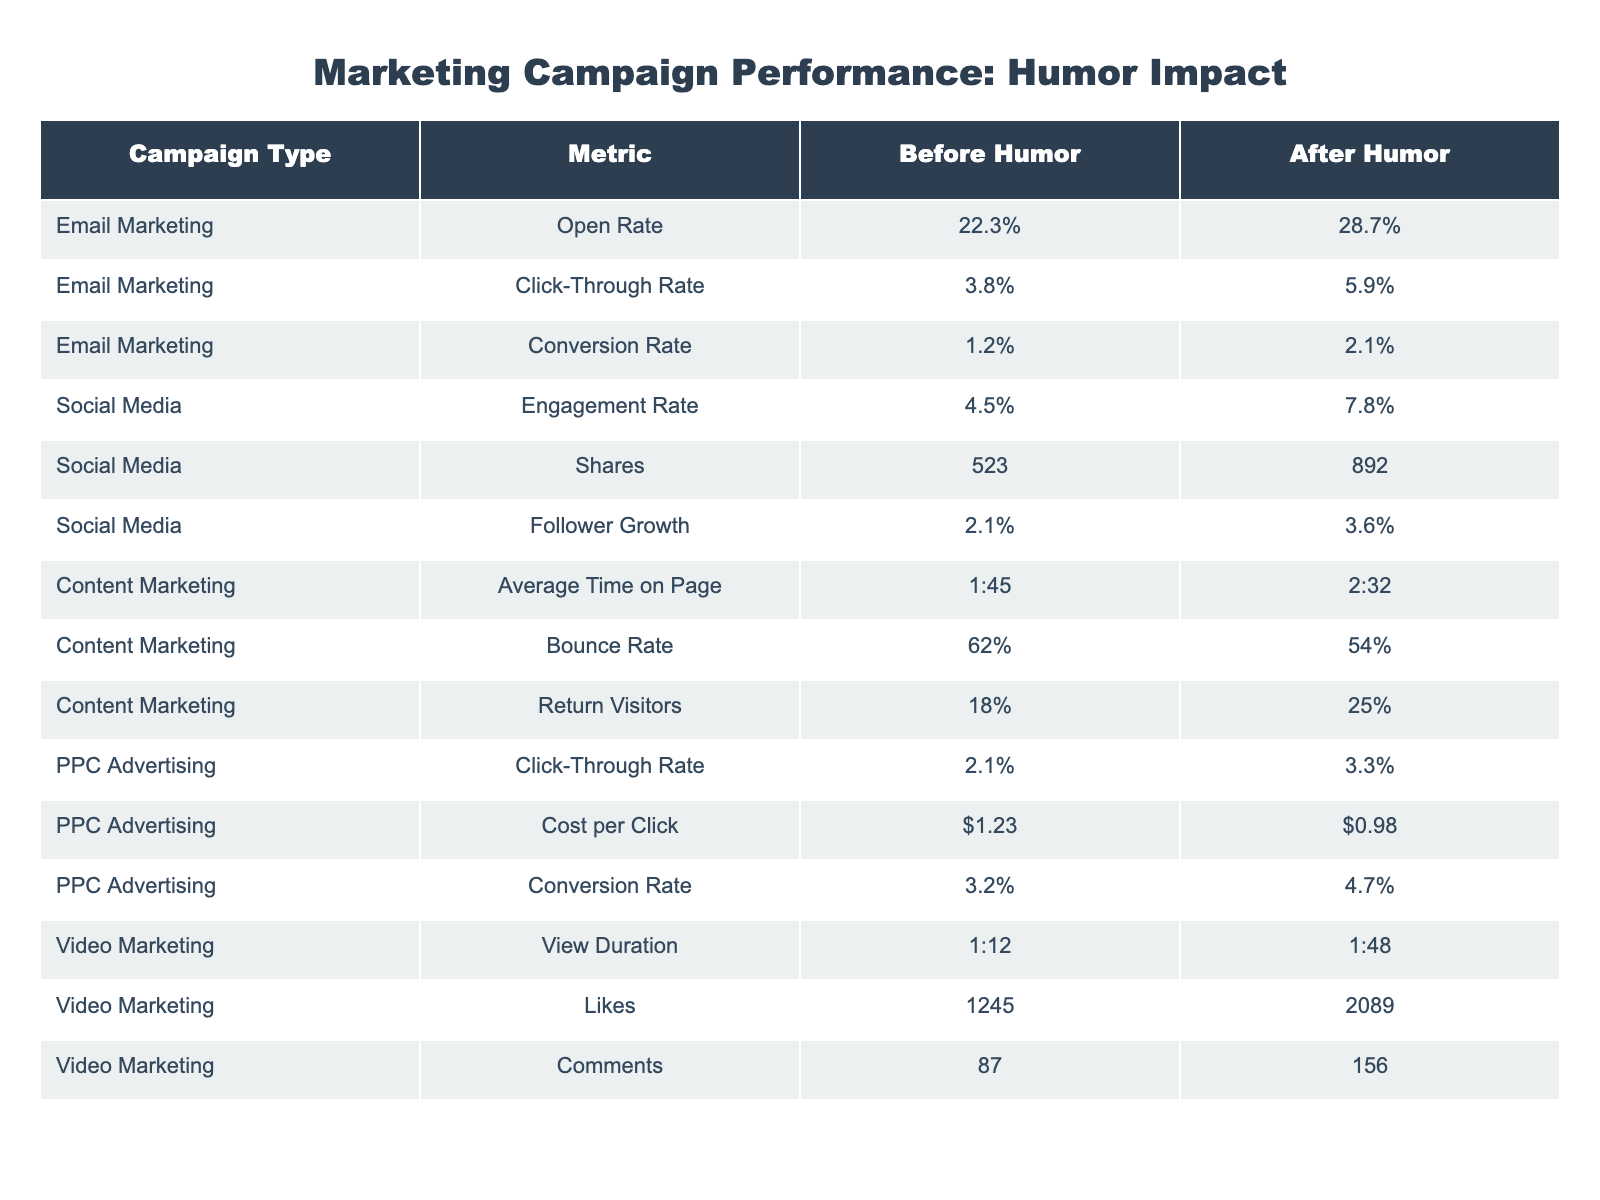What was the open rate for email marketing after humor was incorporated? The table shows that the open rate for email marketing after humor was 28.7%.
Answer: 28.7% Which campaign type experienced the highest increase in engagement rate after humor was added? The social media campaign type had the highest increase in engagement rate, going from 4.5% to 7.8%, which is an increase of 3.3 percentage points.
Answer: Social Media What is the percentage difference in conversion rate for PPC advertising before and after humor? The conversion rate for PPC advertising before humor was 3.2% and after was 4.7%. The percentage difference is calculated as (4.7 - 3.2) = 1.5%.
Answer: 1.5% Did content marketing have a lower bounce rate after incorporating humor? Yes, content marketing's bounce rate improved from 62% to 54% after humor was incorporated.
Answer: Yes What was the average increase in click-through rate for email marketing and PPC advertising combined after humor was added? The click-through rate for email marketing increased from 3.8% to 5.9% (an increase of 2.1%) and for PPC advertising from 2.1% to 3.3% (an increase of 1.2%). The average increase is (2.1 + 1.2) / 2 = 1.65%.
Answer: 1.65% Which campaign had the greatest absolute increase in likes after the incorporation of humor? Video marketing had the greatest absolute increase in likes, from 1245 to 2089. The increase is calculated as 2089 - 1245 = 844.
Answer: 844 What metric improved the least for email marketing after humor was incorporated? The metric that improved the least for email marketing was the conversion rate, which increased from 1.2% to 2.1%, a difference of only 0.9%.
Answer: Conversion Rate Is the cost per click for PPC advertising lower after adding humor? Yes, the cost per click decreased from $1.23 to $0.98 after humor was incorporated.
Answer: Yes What is the percentage of return visitors for content marketing before humor? The table indicates that the percentage of return visitors for content marketing before humor was 18%.
Answer: 18% What was the total increase in shares for social media after humor? The total increase in shares for social media is calculated by subtracting the number of shares before humor (523) from the number of shares after (892), which equals 369.
Answer: 369 Which campaign type had the longest increase in average time on page after humor was incorporated? Content marketing had the longest increase in average time on page, from 1:45 minutes to 2:32 minutes, an increase of 47 seconds.
Answer: Content Marketing 